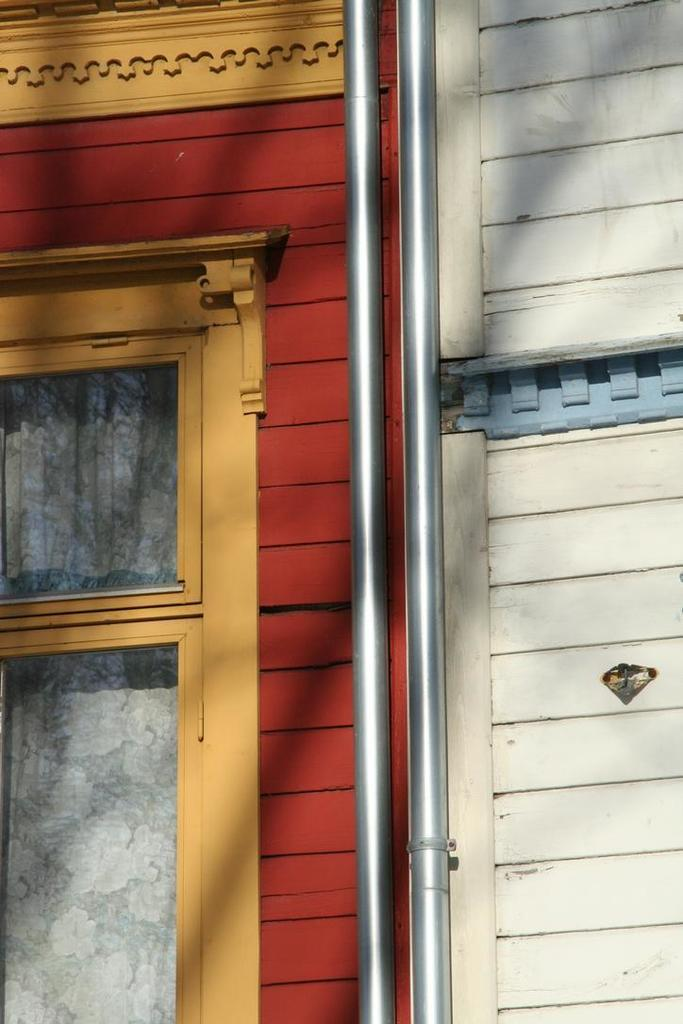What can be seen on the wall in the image? There is a wall with a design in the image. What feature is present in the wall? There is a window in the wall. What is visible through the window? A curtain is visible through the window. What is attached to the wall? There are rods attached to the wall. What type of bat can be seen flying near the moon in the image? There is no bat or moon present in the image; it only features a wall with a design, a window, a curtain, and rods. 